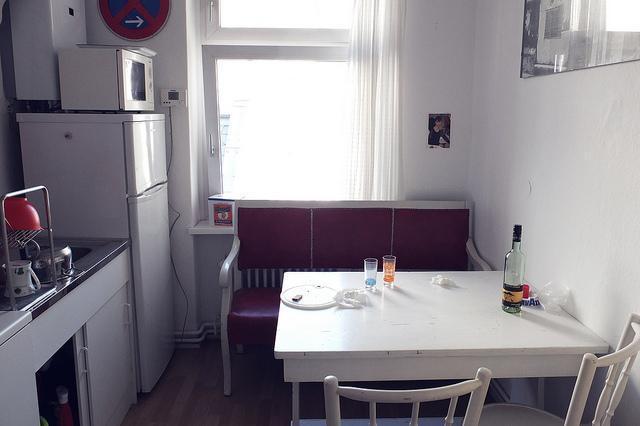How many chairs are there?
Give a very brief answer. 3. How many microwaves are in the picture?
Give a very brief answer. 1. How many  bikes are pictured?
Give a very brief answer. 0. 